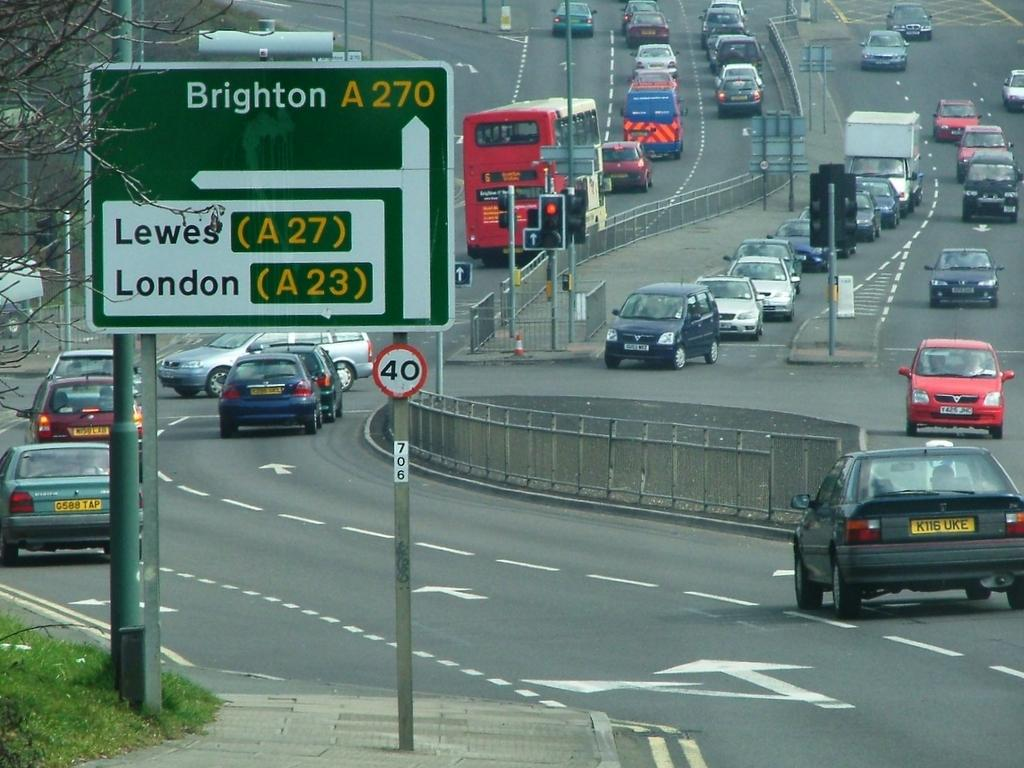What can be seen on the road in the image? There are fleets of vehicles on the road in the image. What type of structure can be seen in the image? There is a fence in the image. What are the boards used for in the image? The boards are likely used for signage or advertisements in the image. What type of vegetation is present in the image? There is grass in the image. What type of architectural elements can be seen in the image? There are pillars and light poles in the image. What type of natural elements can be seen in the image? There are trees in the image. What type of traffic control devices are present in the image? There are stoppers in the image. What can be inferred about the time of day when the image was taken? The image was likely taken during the day, as there is sufficient light to see the details clearly. How many cats are sitting on the fence in the image? There are no cats present in the image. What type of rings can be seen on the pillars in the image? There are no rings present on the pillars in the image. 